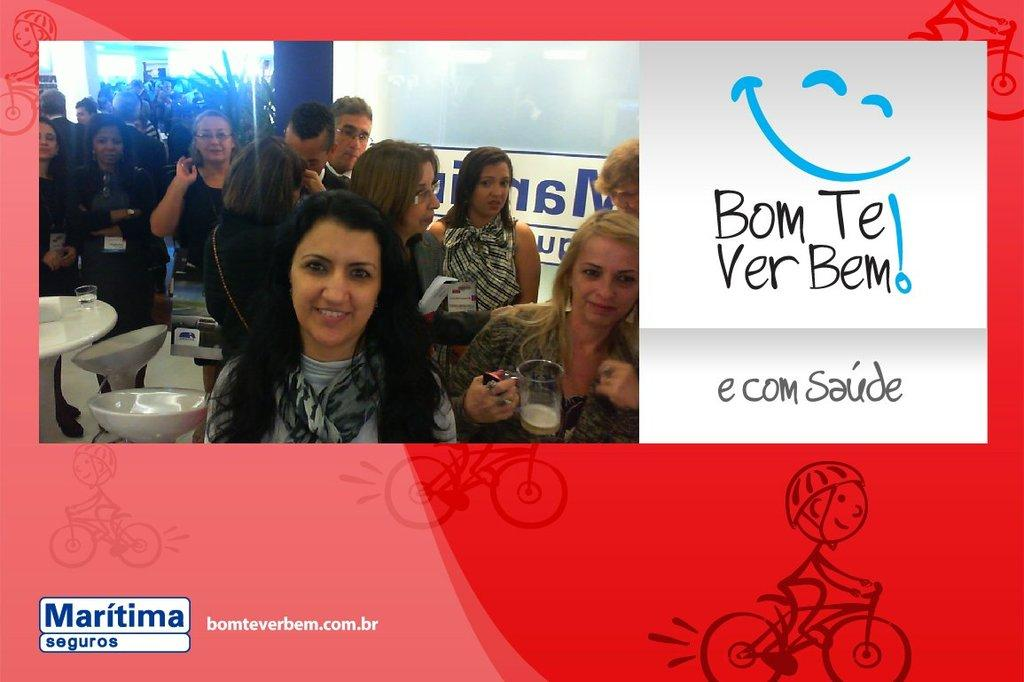Who or what is present in the image? There are people in the image. Where are the people located within the image? The people are located at the left corner of the image. How many swings are visible in the image? There are no swings present in the image. What type of party is taking place in the image? There is no party depicted in the image; it only shows people located at the left corner. 